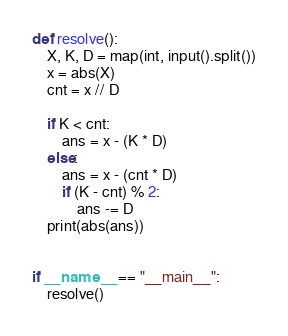<code> <loc_0><loc_0><loc_500><loc_500><_Python_>
def resolve():
    X, K, D = map(int, input().split())
    x = abs(X)
    cnt = x // D

    if K < cnt:
        ans = x - (K * D)
    else:
        ans = x - (cnt * D)
        if (K - cnt) % 2:
            ans -= D
    print(abs(ans))


if __name__ == "__main__":
    resolve()</code> 